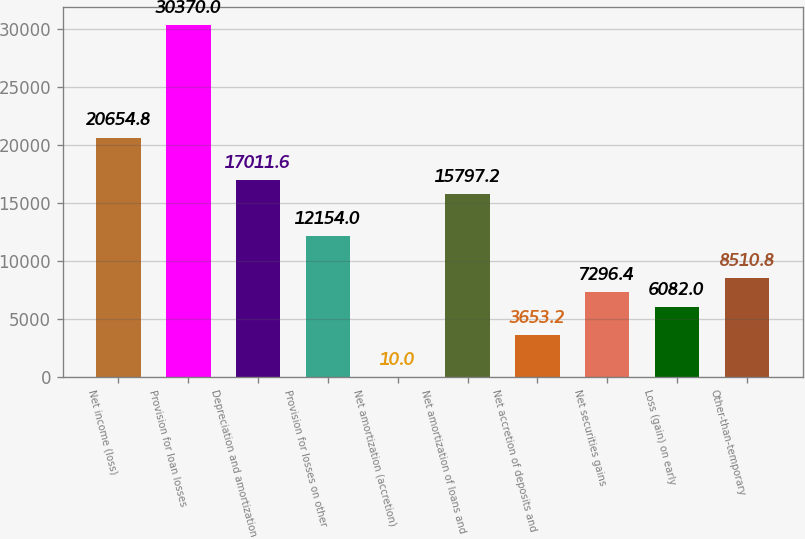Convert chart to OTSL. <chart><loc_0><loc_0><loc_500><loc_500><bar_chart><fcel>Net income (loss)<fcel>Provision for loan losses<fcel>Depreciation and amortization<fcel>Provision for losses on other<fcel>Net amortization (accretion)<fcel>Net amortization of loans and<fcel>Net accretion of deposits and<fcel>Net securities gains<fcel>Loss (gain) on early<fcel>Other-than-temporary<nl><fcel>20654.8<fcel>30370<fcel>17011.6<fcel>12154<fcel>10<fcel>15797.2<fcel>3653.2<fcel>7296.4<fcel>6082<fcel>8510.8<nl></chart> 